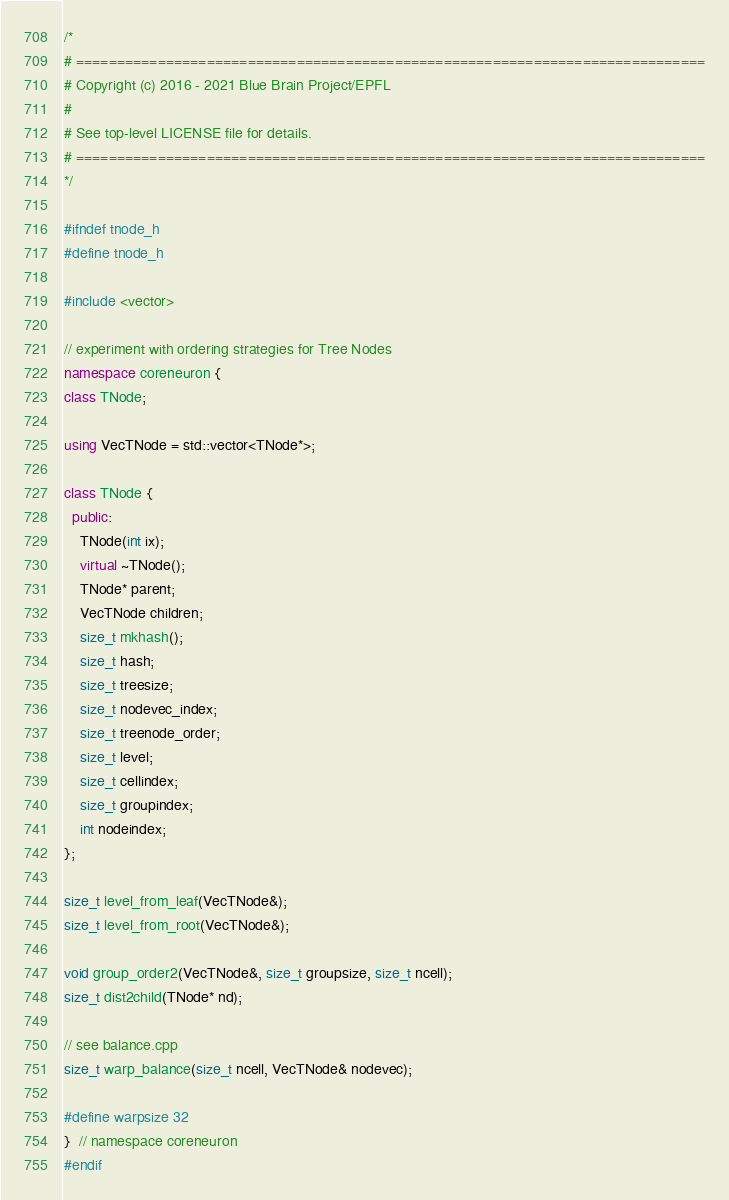<code> <loc_0><loc_0><loc_500><loc_500><_C++_>/*
# =============================================================================
# Copyright (c) 2016 - 2021 Blue Brain Project/EPFL
#
# See top-level LICENSE file for details.
# =============================================================================
*/

#ifndef tnode_h
#define tnode_h

#include <vector>

// experiment with ordering strategies for Tree Nodes
namespace coreneuron {
class TNode;

using VecTNode = std::vector<TNode*>;

class TNode {
  public:
    TNode(int ix);
    virtual ~TNode();
    TNode* parent;
    VecTNode children;
    size_t mkhash();
    size_t hash;
    size_t treesize;
    size_t nodevec_index;
    size_t treenode_order;
    size_t level;
    size_t cellindex;
    size_t groupindex;
    int nodeindex;
};

size_t level_from_leaf(VecTNode&);
size_t level_from_root(VecTNode&);

void group_order2(VecTNode&, size_t groupsize, size_t ncell);
size_t dist2child(TNode* nd);

// see balance.cpp
size_t warp_balance(size_t ncell, VecTNode& nodevec);

#define warpsize 32
}  // namespace coreneuron
#endif
</code> 